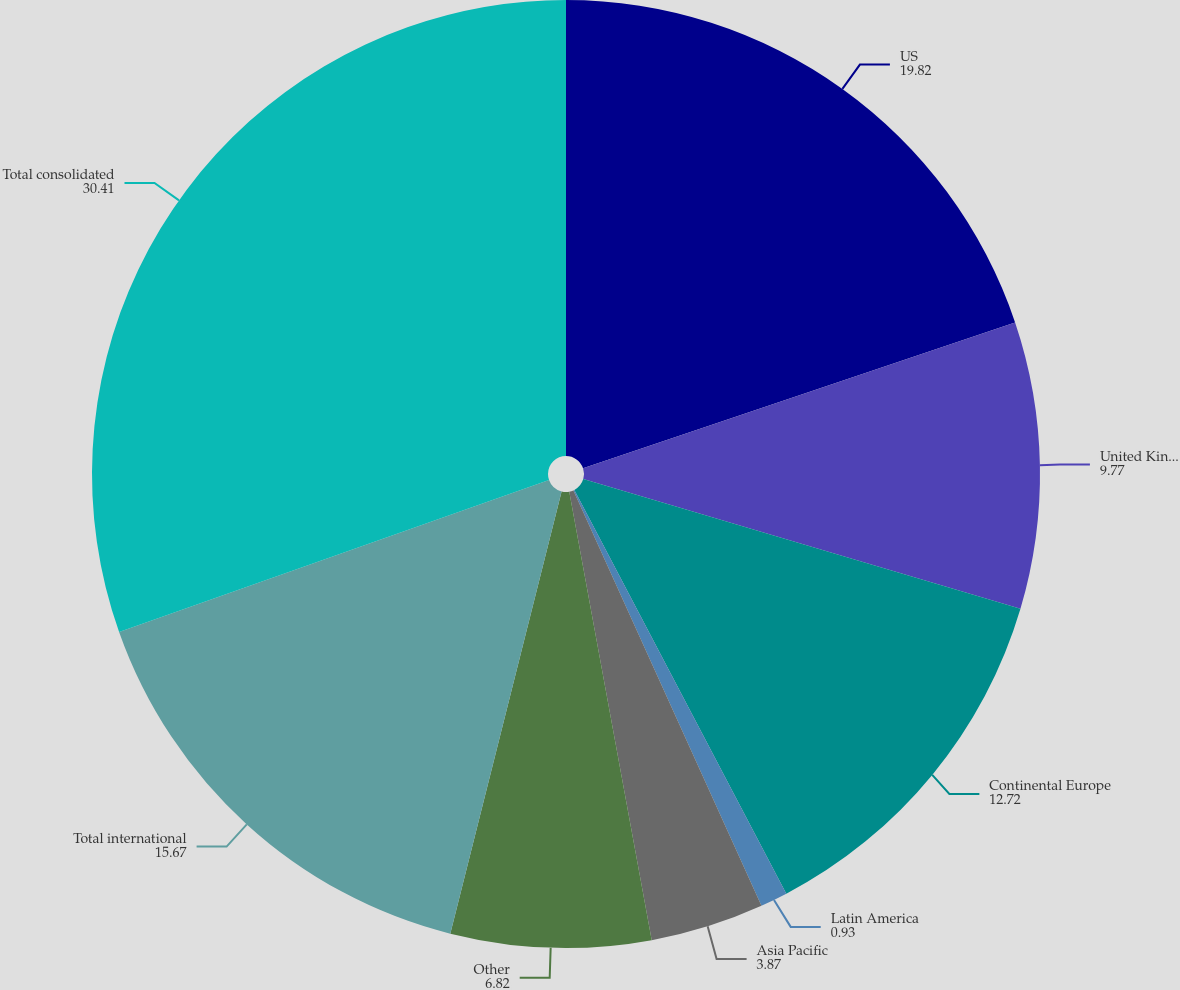Convert chart to OTSL. <chart><loc_0><loc_0><loc_500><loc_500><pie_chart><fcel>US<fcel>United Kingdom<fcel>Continental Europe<fcel>Latin America<fcel>Asia Pacific<fcel>Other<fcel>Total international<fcel>Total consolidated<nl><fcel>19.82%<fcel>9.77%<fcel>12.72%<fcel>0.93%<fcel>3.87%<fcel>6.82%<fcel>15.67%<fcel>30.41%<nl></chart> 